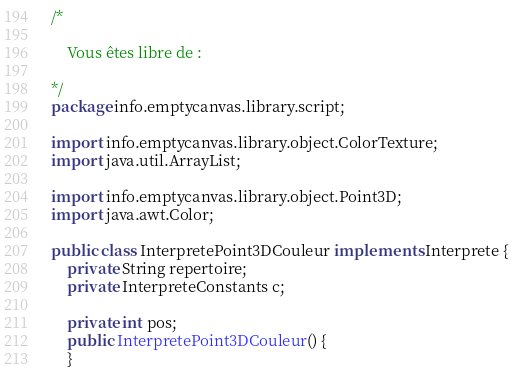<code> <loc_0><loc_0><loc_500><loc_500><_Java_>/*

    Vous êtes libre de :

*/
package info.emptycanvas.library.script;

import info.emptycanvas.library.object.ColorTexture;
import java.util.ArrayList;

import info.emptycanvas.library.object.Point3D;
import java.awt.Color;

public class InterpretePoint3DCouleur implements Interprete {
    private String repertoire;
    private InterpreteConstants c;

    private int pos;
    public InterpretePoint3DCouleur() {
    }
</code> 